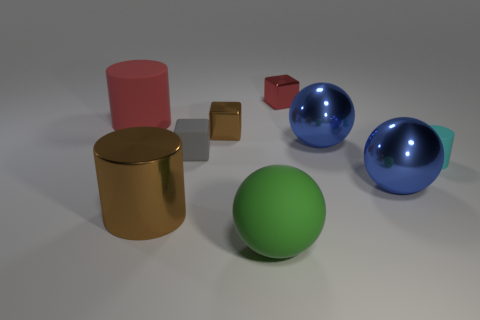Subtract all cylinders. How many objects are left? 6 Subtract 0 gray cylinders. How many objects are left? 9 Subtract all red cubes. Subtract all metallic cylinders. How many objects are left? 7 Add 4 small cyan cylinders. How many small cyan cylinders are left? 5 Add 8 metal cylinders. How many metal cylinders exist? 9 